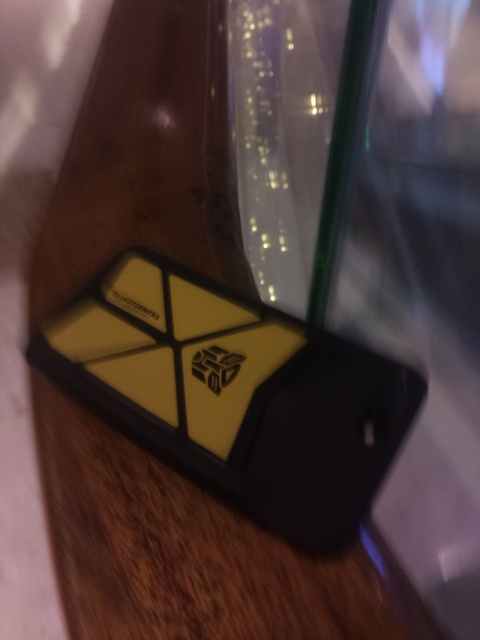How is the tilt of this image?
A. significantly
B. slightly
C. perfectly
D. completely
Answer with the option's letter from the given choices directly.
 B. 